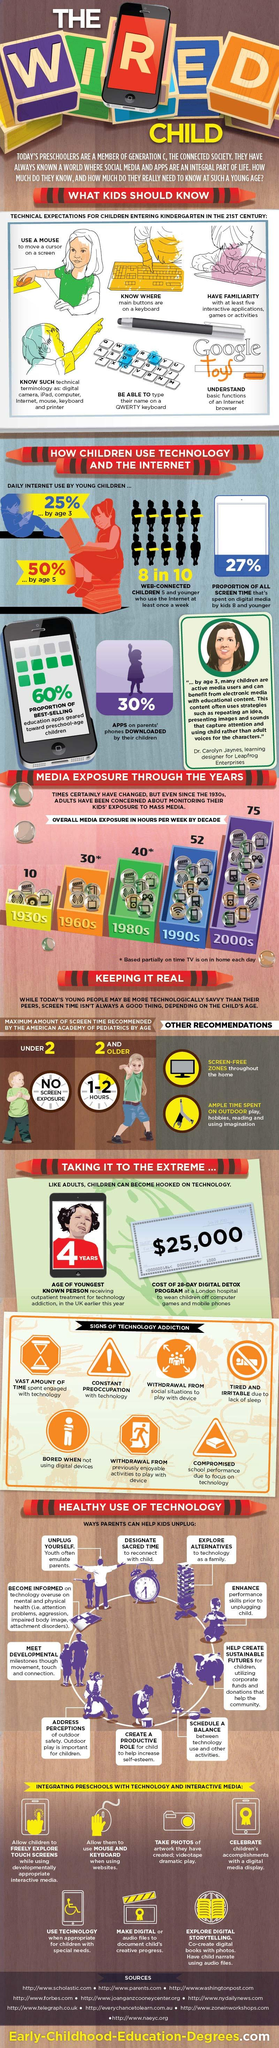Mention a couple of crucial points in this snapshot. The daily internet usage of a 3-year-old child is approximately 25%. The 1990s children have a significantly higher weekly exposure when compared to the 1980s. It is evident that there are seven signs of technology addiction displayed here. According to pediatricians, children of age 2 should be allowed to have a maximum of 1 to 2 hours of screen time per day. In a technology-integrated preschool, the child's creative progress is documented using either digital or audio files. 